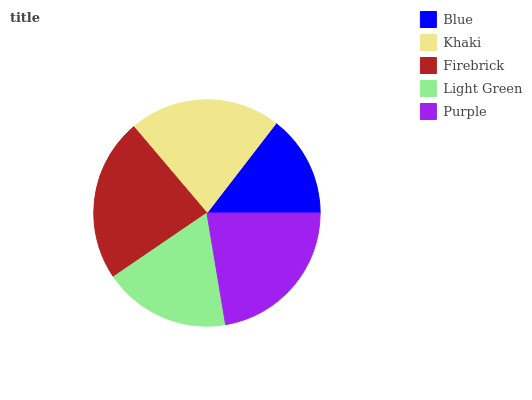Is Blue the minimum?
Answer yes or no. Yes. Is Firebrick the maximum?
Answer yes or no. Yes. Is Khaki the minimum?
Answer yes or no. No. Is Khaki the maximum?
Answer yes or no. No. Is Khaki greater than Blue?
Answer yes or no. Yes. Is Blue less than Khaki?
Answer yes or no. Yes. Is Blue greater than Khaki?
Answer yes or no. No. Is Khaki less than Blue?
Answer yes or no. No. Is Khaki the high median?
Answer yes or no. Yes. Is Khaki the low median?
Answer yes or no. Yes. Is Firebrick the high median?
Answer yes or no. No. Is Light Green the low median?
Answer yes or no. No. 